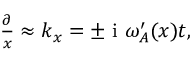<formula> <loc_0><loc_0><loc_500><loc_500>\begin{array} { r } { \frac { \partial } { x } \approx k _ { x } = \pm i \omega _ { A } ^ { \prime } ( x ) t , } \end{array}</formula> 